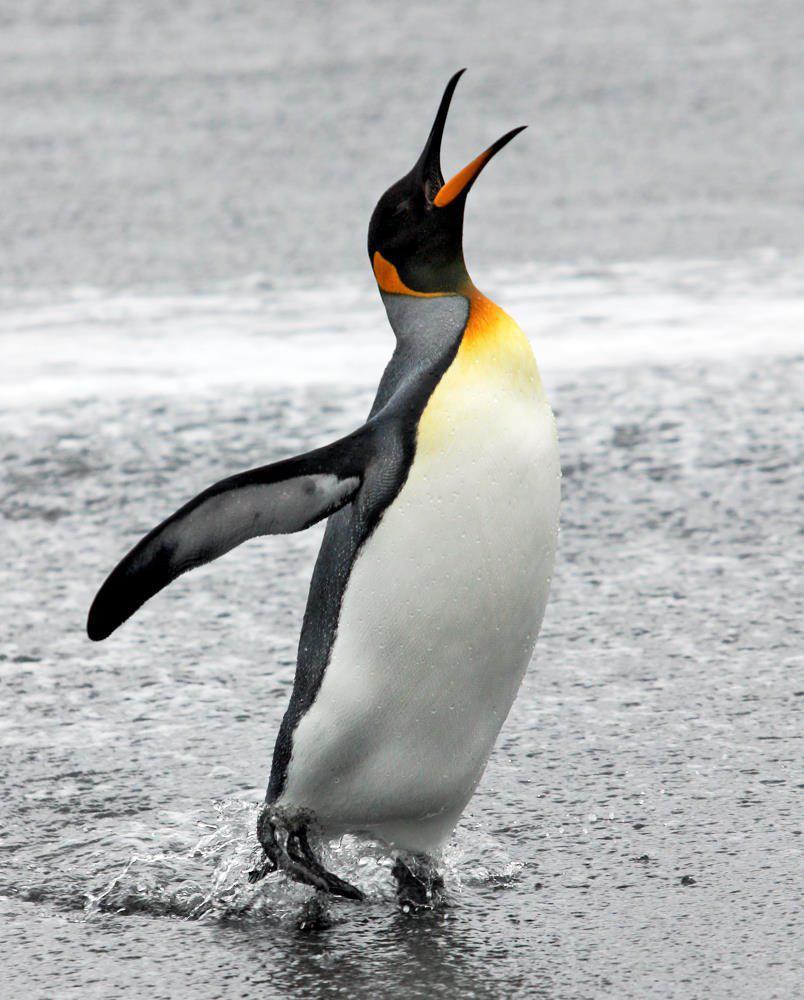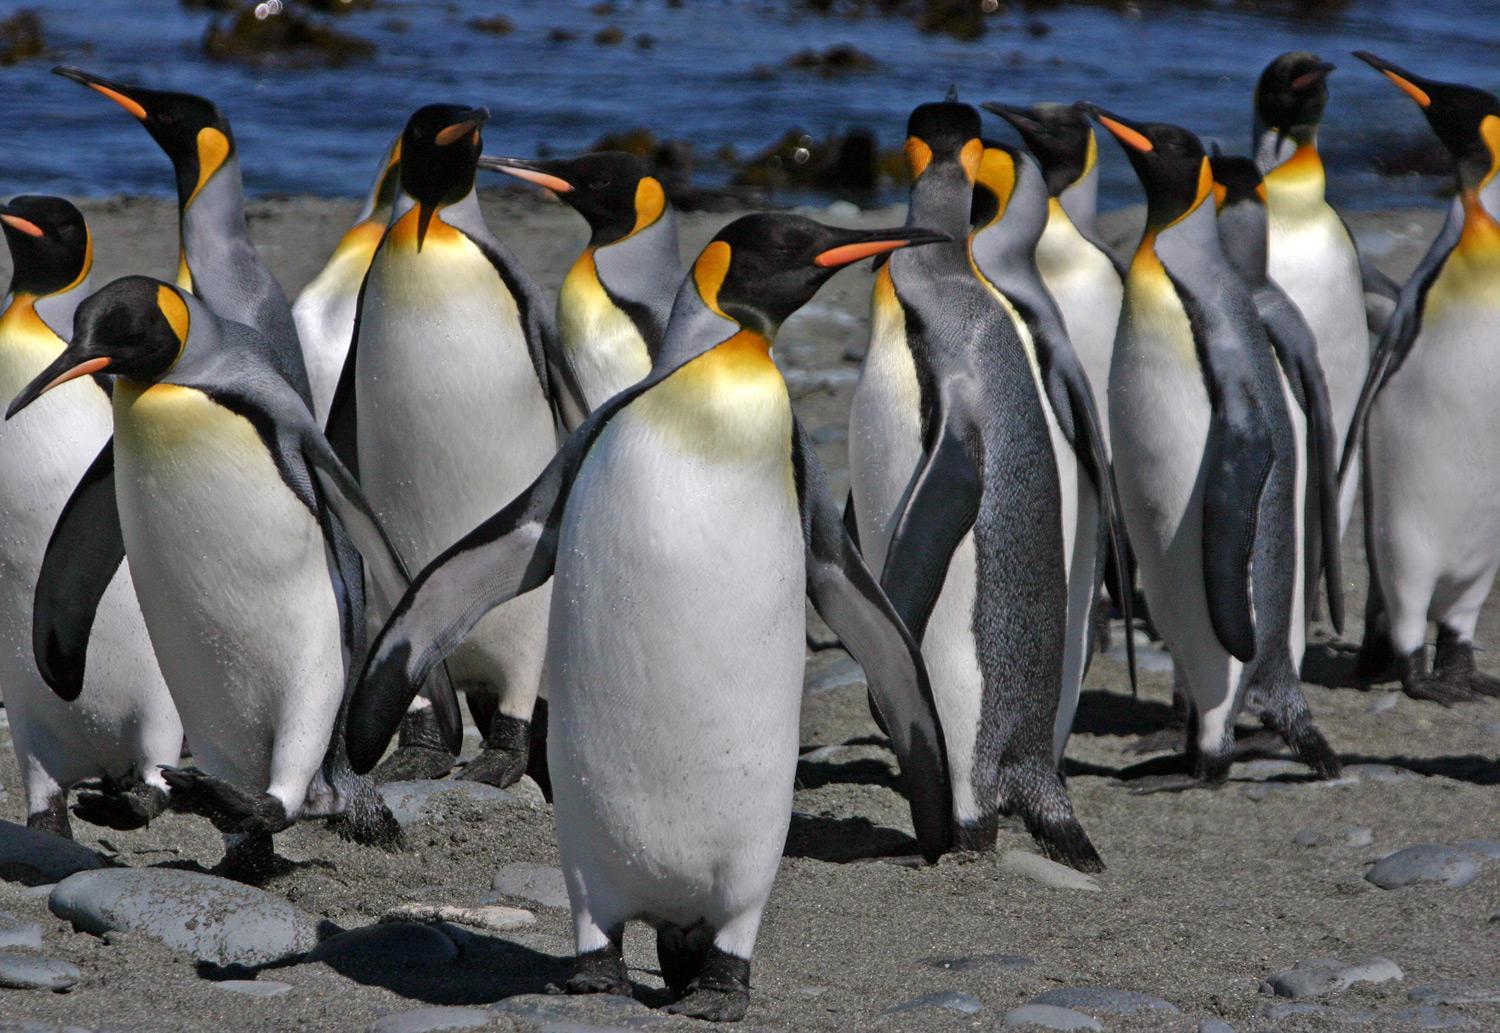The first image is the image on the left, the second image is the image on the right. Considering the images on both sides, is "the penguin in the image on the right is looking down" valid? Answer yes or no. No. The first image is the image on the left, the second image is the image on the right. Examine the images to the left and right. Is the description "In one image, exactly four penguins are standing together." accurate? Answer yes or no. No. 